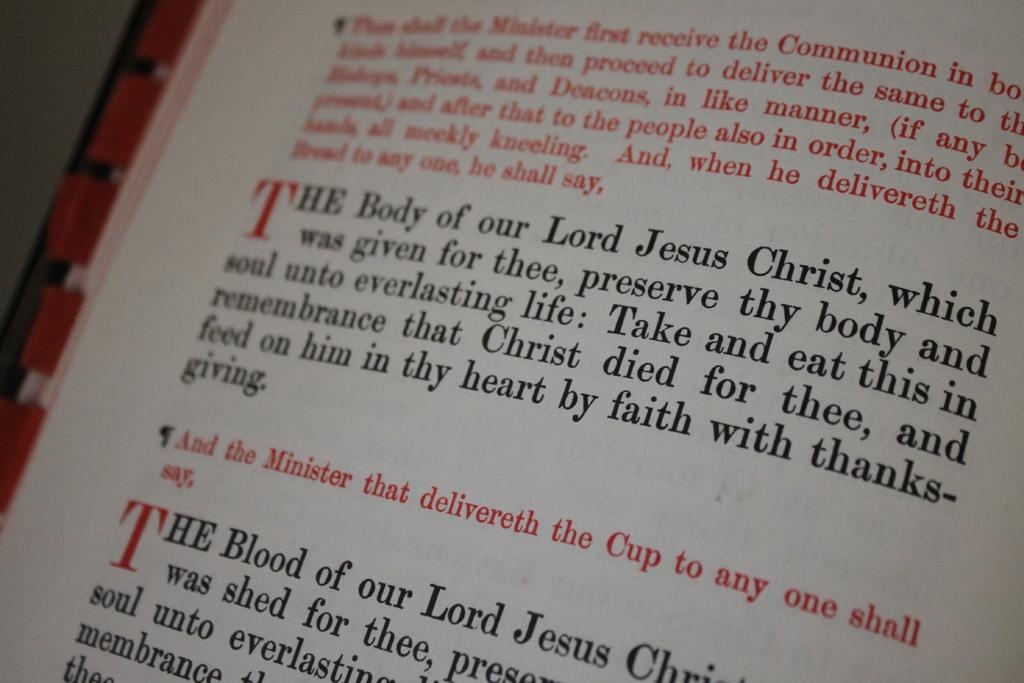What letter is in large red text 2 times?
Provide a short and direct response. T. What us one sentence written in red?
Your answer should be compact. And the minister that delivereth the cup to any one shall say. 